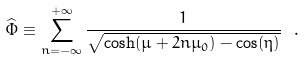Convert formula to latex. <formula><loc_0><loc_0><loc_500><loc_500>\widehat { \Phi } \equiv \sum _ { n = - \infty } ^ { + \infty } \frac { 1 } { \sqrt { \cosh ( \mu + 2 n \mu _ { 0 } ) - \cos ( \eta ) } } \ .</formula> 